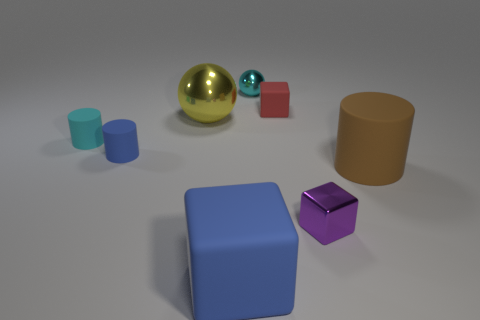Subtract all tiny red matte cubes. How many cubes are left? 2 Add 1 blue things. How many objects exist? 9 Subtract all blue cylinders. How many cylinders are left? 2 Subtract 1 blocks. How many blocks are left? 2 Subtract all cubes. How many objects are left? 5 Subtract all red cylinders. Subtract all gray balls. How many cylinders are left? 3 Subtract all gray cylinders. How many gray cubes are left? 0 Subtract all large gray shiny cubes. Subtract all blocks. How many objects are left? 5 Add 7 large brown matte things. How many large brown matte things are left? 8 Add 2 spheres. How many spheres exist? 4 